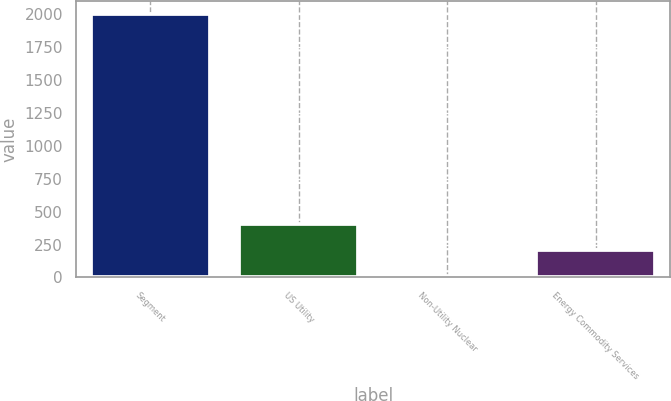<chart> <loc_0><loc_0><loc_500><loc_500><bar_chart><fcel>Segment<fcel>US Utility<fcel>Non-Utility Nuclear<fcel>Energy Commodity Services<nl><fcel>2001<fcel>406.6<fcel>8<fcel>207.3<nl></chart> 